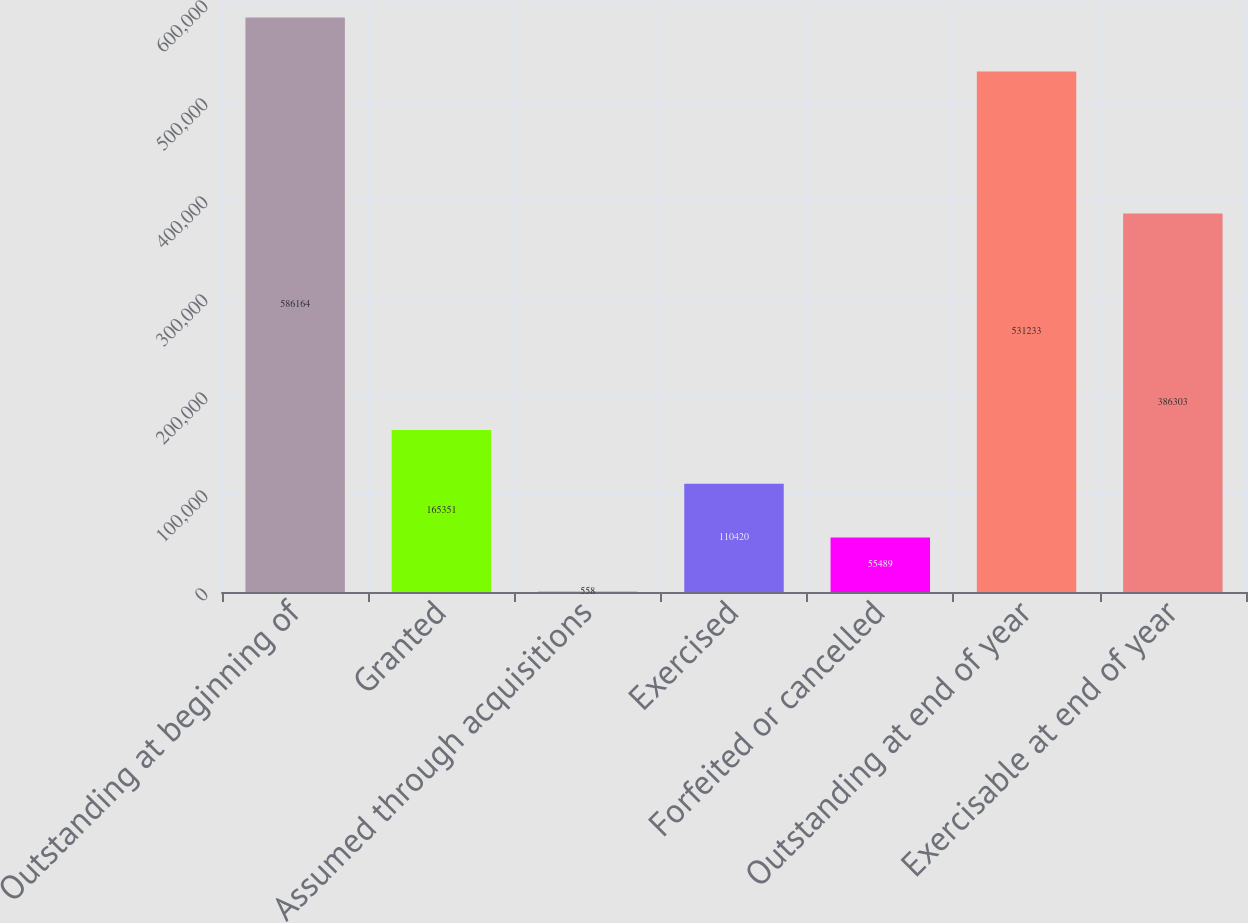<chart> <loc_0><loc_0><loc_500><loc_500><bar_chart><fcel>Outstanding at beginning of<fcel>Granted<fcel>Assumed through acquisitions<fcel>Exercised<fcel>Forfeited or cancelled<fcel>Outstanding at end of year<fcel>Exercisable at end of year<nl><fcel>586164<fcel>165351<fcel>558<fcel>110420<fcel>55489<fcel>531233<fcel>386303<nl></chart> 